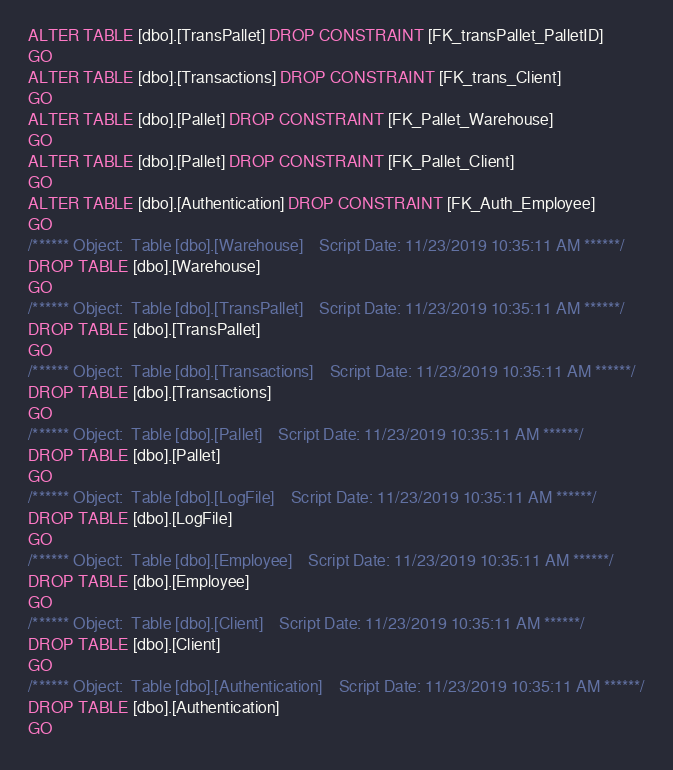<code> <loc_0><loc_0><loc_500><loc_500><_SQL_>ALTER TABLE [dbo].[TransPallet] DROP CONSTRAINT [FK_transPallet_PalletID]
GO
ALTER TABLE [dbo].[Transactions] DROP CONSTRAINT [FK_trans_Client]
GO
ALTER TABLE [dbo].[Pallet] DROP CONSTRAINT [FK_Pallet_Warehouse]
GO
ALTER TABLE [dbo].[Pallet] DROP CONSTRAINT [FK_Pallet_Client]
GO
ALTER TABLE [dbo].[Authentication] DROP CONSTRAINT [FK_Auth_Employee]
GO
/****** Object:  Table [dbo].[Warehouse]    Script Date: 11/23/2019 10:35:11 AM ******/
DROP TABLE [dbo].[Warehouse]
GO
/****** Object:  Table [dbo].[TransPallet]    Script Date: 11/23/2019 10:35:11 AM ******/
DROP TABLE [dbo].[TransPallet]
GO
/****** Object:  Table [dbo].[Transactions]    Script Date: 11/23/2019 10:35:11 AM ******/
DROP TABLE [dbo].[Transactions]
GO
/****** Object:  Table [dbo].[Pallet]    Script Date: 11/23/2019 10:35:11 AM ******/
DROP TABLE [dbo].[Pallet]
GO
/****** Object:  Table [dbo].[LogFile]    Script Date: 11/23/2019 10:35:11 AM ******/
DROP TABLE [dbo].[LogFile]
GO
/****** Object:  Table [dbo].[Employee]    Script Date: 11/23/2019 10:35:11 AM ******/
DROP TABLE [dbo].[Employee]
GO
/****** Object:  Table [dbo].[Client]    Script Date: 11/23/2019 10:35:11 AM ******/
DROP TABLE [dbo].[Client]
GO
/****** Object:  Table [dbo].[Authentication]    Script Date: 11/23/2019 10:35:11 AM ******/
DROP TABLE [dbo].[Authentication]
GO
</code> 